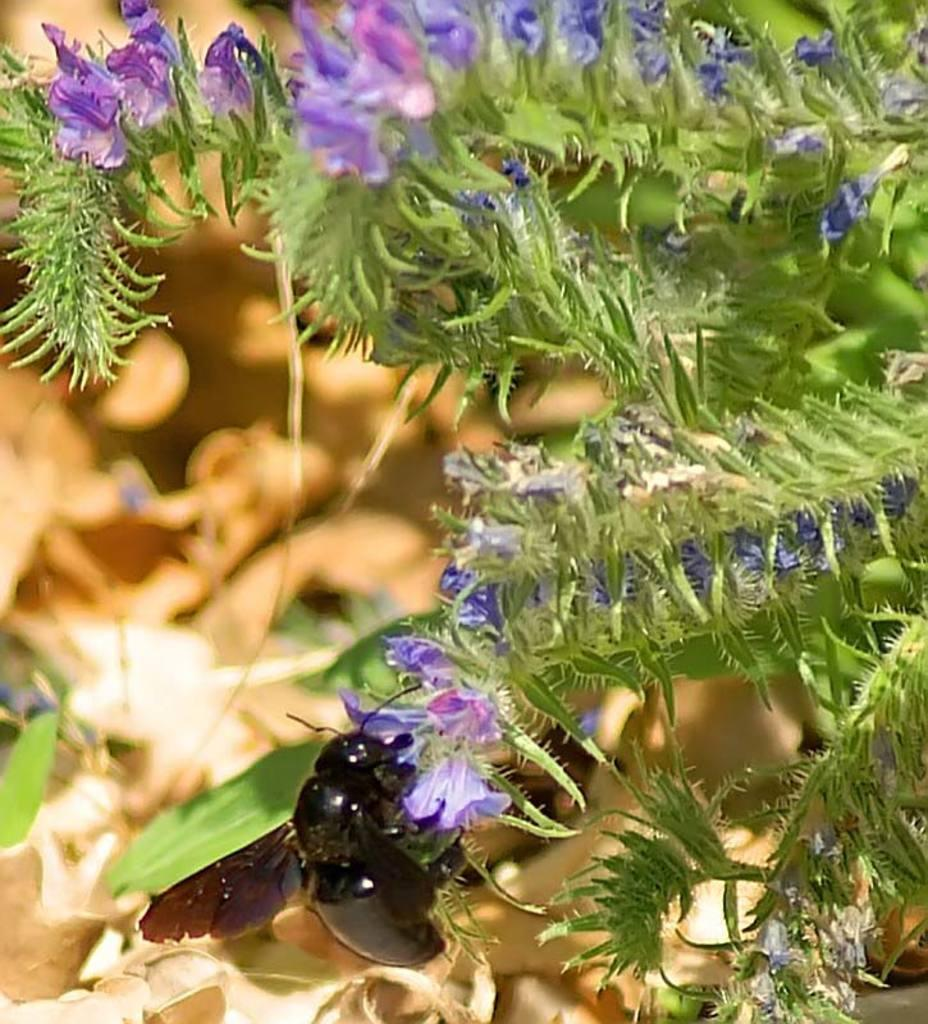What type of flowers can be seen in the image? There are purple color flowers in the image. What other elements can be found in the image besides the flowers? There are green leaves and a black color insect in the image. What is the color of the background in the image? The background of the image is in brown color. What type of memory is being used by the insect in the image? There is no indication in the image that the insect is using any type of memory. 